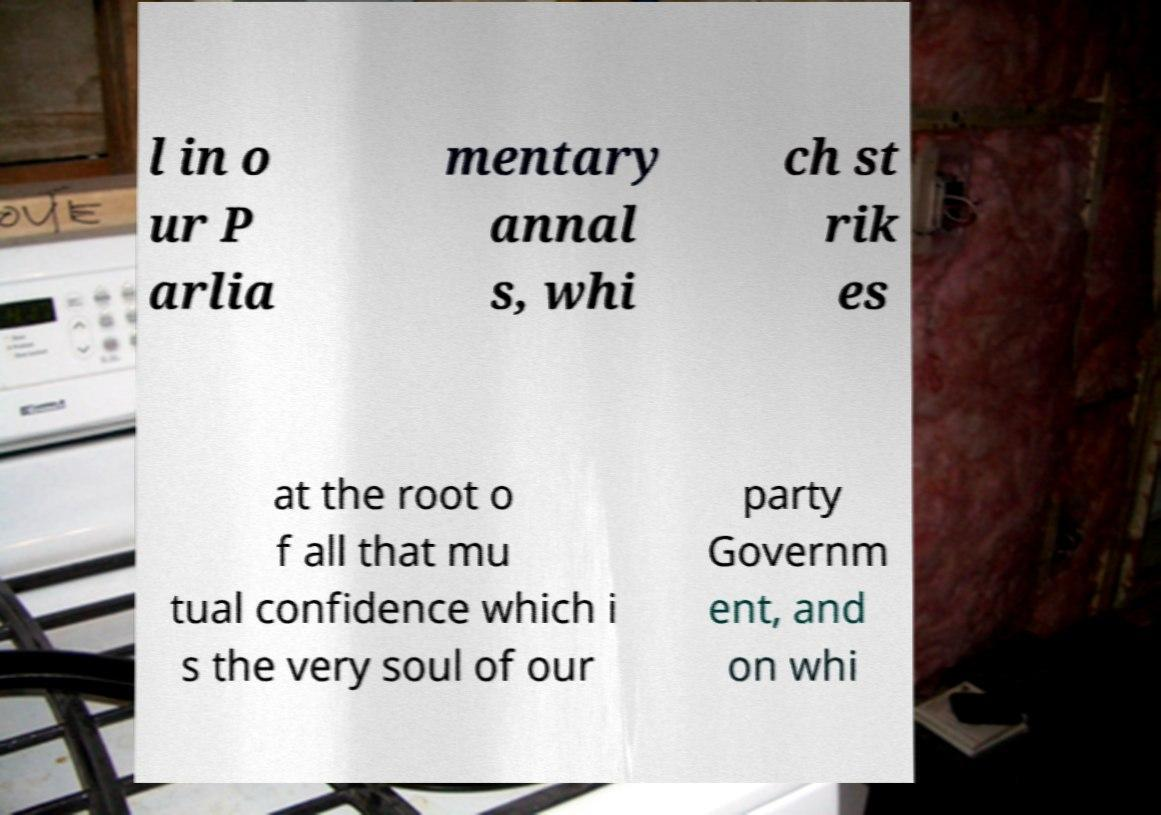Can you read and provide the text displayed in the image?This photo seems to have some interesting text. Can you extract and type it out for me? l in o ur P arlia mentary annal s, whi ch st rik es at the root o f all that mu tual confidence which i s the very soul of our party Governm ent, and on whi 